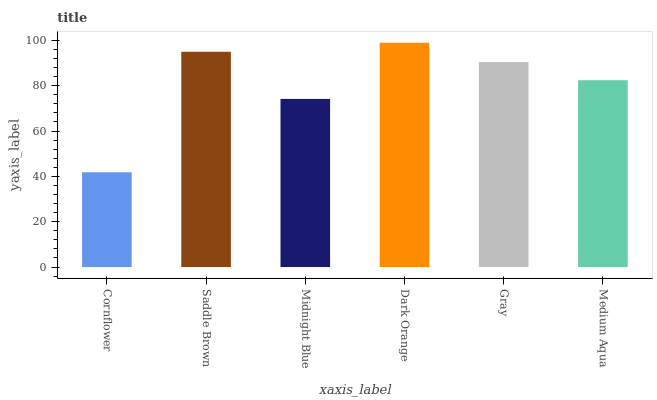Is Cornflower the minimum?
Answer yes or no. Yes. Is Dark Orange the maximum?
Answer yes or no. Yes. Is Saddle Brown the minimum?
Answer yes or no. No. Is Saddle Brown the maximum?
Answer yes or no. No. Is Saddle Brown greater than Cornflower?
Answer yes or no. Yes. Is Cornflower less than Saddle Brown?
Answer yes or no. Yes. Is Cornflower greater than Saddle Brown?
Answer yes or no. No. Is Saddle Brown less than Cornflower?
Answer yes or no. No. Is Gray the high median?
Answer yes or no. Yes. Is Medium Aqua the low median?
Answer yes or no. Yes. Is Dark Orange the high median?
Answer yes or no. No. Is Gray the low median?
Answer yes or no. No. 